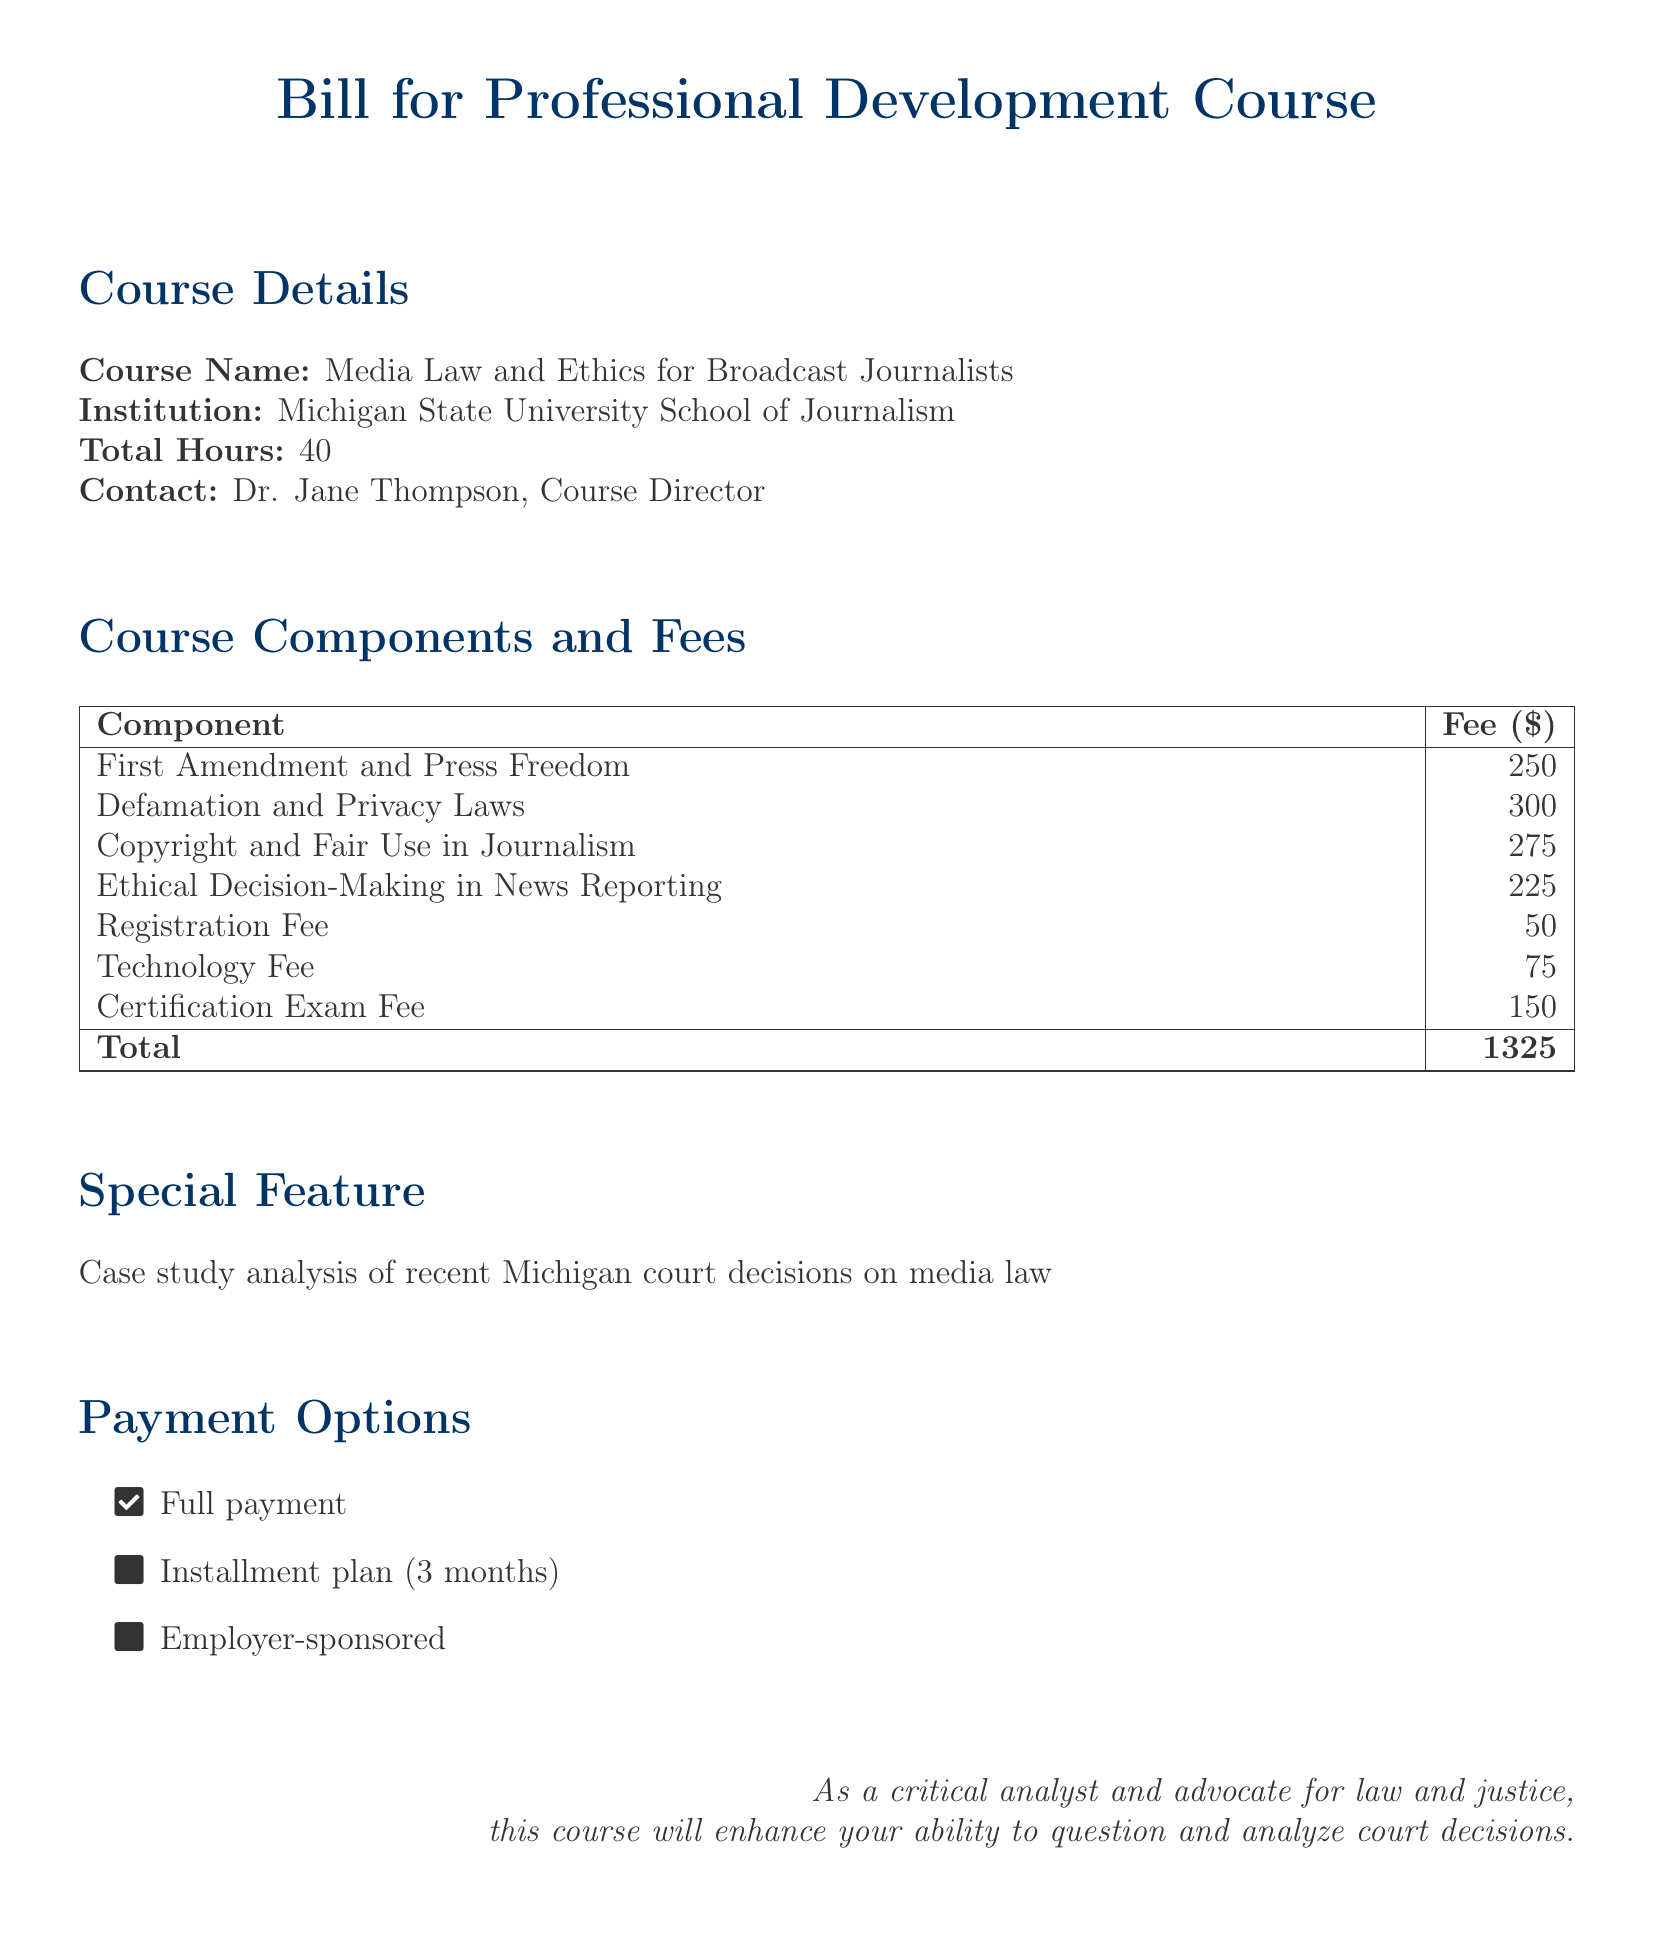What is the course name? The document specifies the course name as "Media Law and Ethics for Broadcast Journalists."
Answer: Media Law and Ethics for Broadcast Journalists Who is the course director? The document mentions Dr. Jane Thompson as the Course Director.
Answer: Dr. Jane Thompson What is the registration fee? The document lists the registration fee as one of the components, which is $50.
Answer: 50 What is the total course fee? The total of all course components and fees listed in the document is $1325.
Answer: 1325 How many total hours is the course? The document states that the total hours for the course is 40.
Answer: 40 What unique feature does this course offer? The document highlights a special feature, which is the case study analysis of recent Michigan court decisions on media law.
Answer: Case study analysis of recent Michigan court decisions on media law What payment option allows monthly payments? The document mentions an installment plan option for payment over three months.
Answer: Installment plan (3 months) Which component has the highest fee? The document indicates that the component "Defamation and Privacy Laws" has the highest fee of $300.
Answer: 300 How many components are listed in the fee structure? The fee structure in the document lists a total of 7 components.
Answer: 7 